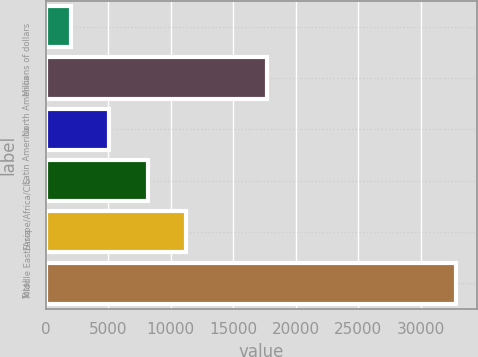Convert chart to OTSL. <chart><loc_0><loc_0><loc_500><loc_500><bar_chart><fcel>Millions of dollars<fcel>North America<fcel>Latin America<fcel>Europe/Africa/CIS<fcel>Middle East/Asia<fcel>Total<nl><fcel>2014<fcel>17698<fcel>5099.6<fcel>8185.2<fcel>11270.8<fcel>32870<nl></chart> 